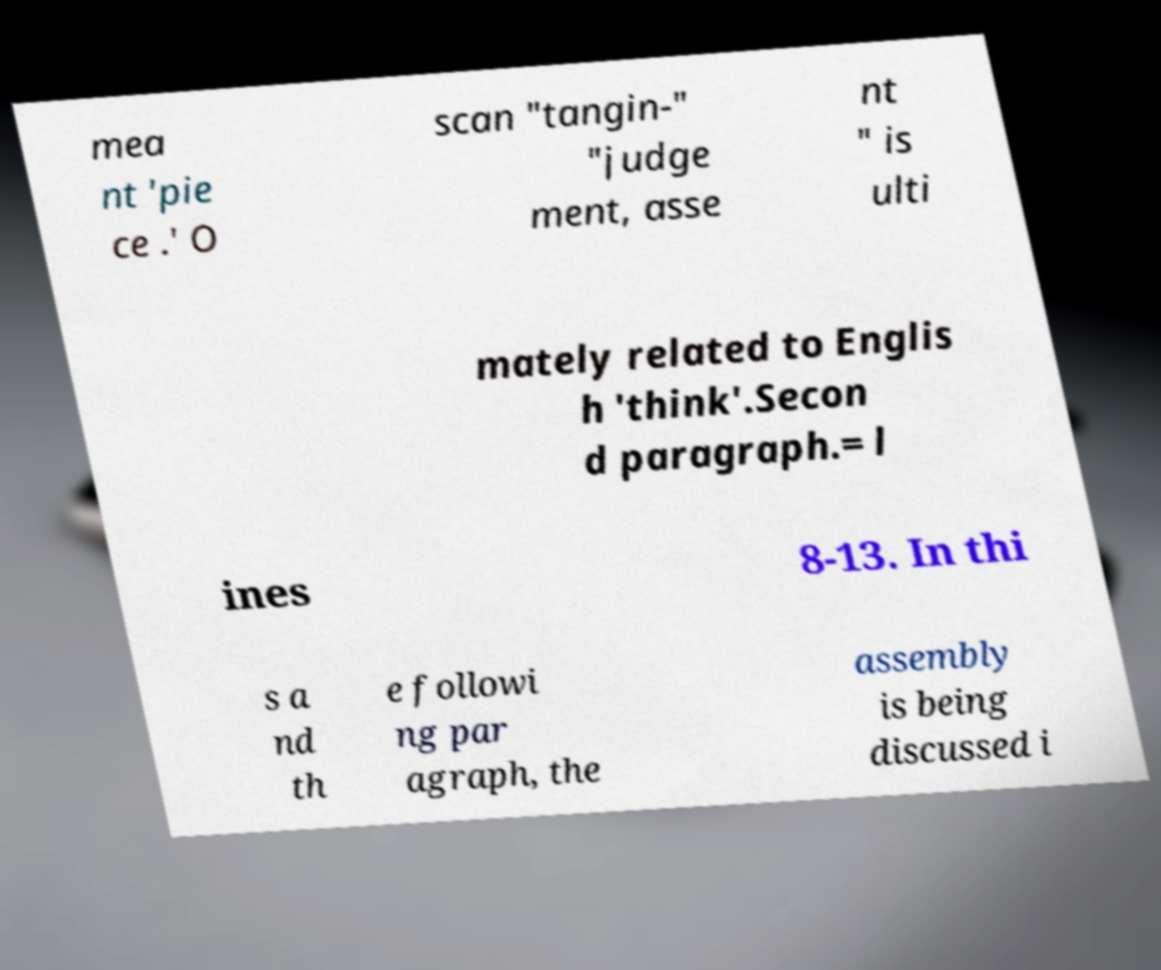I need the written content from this picture converted into text. Can you do that? mea nt 'pie ce .' O scan "tangin-" "judge ment, asse nt " is ulti mately related to Englis h 'think'.Secon d paragraph.= l ines 8-13. In thi s a nd th e followi ng par agraph, the assembly is being discussed i 